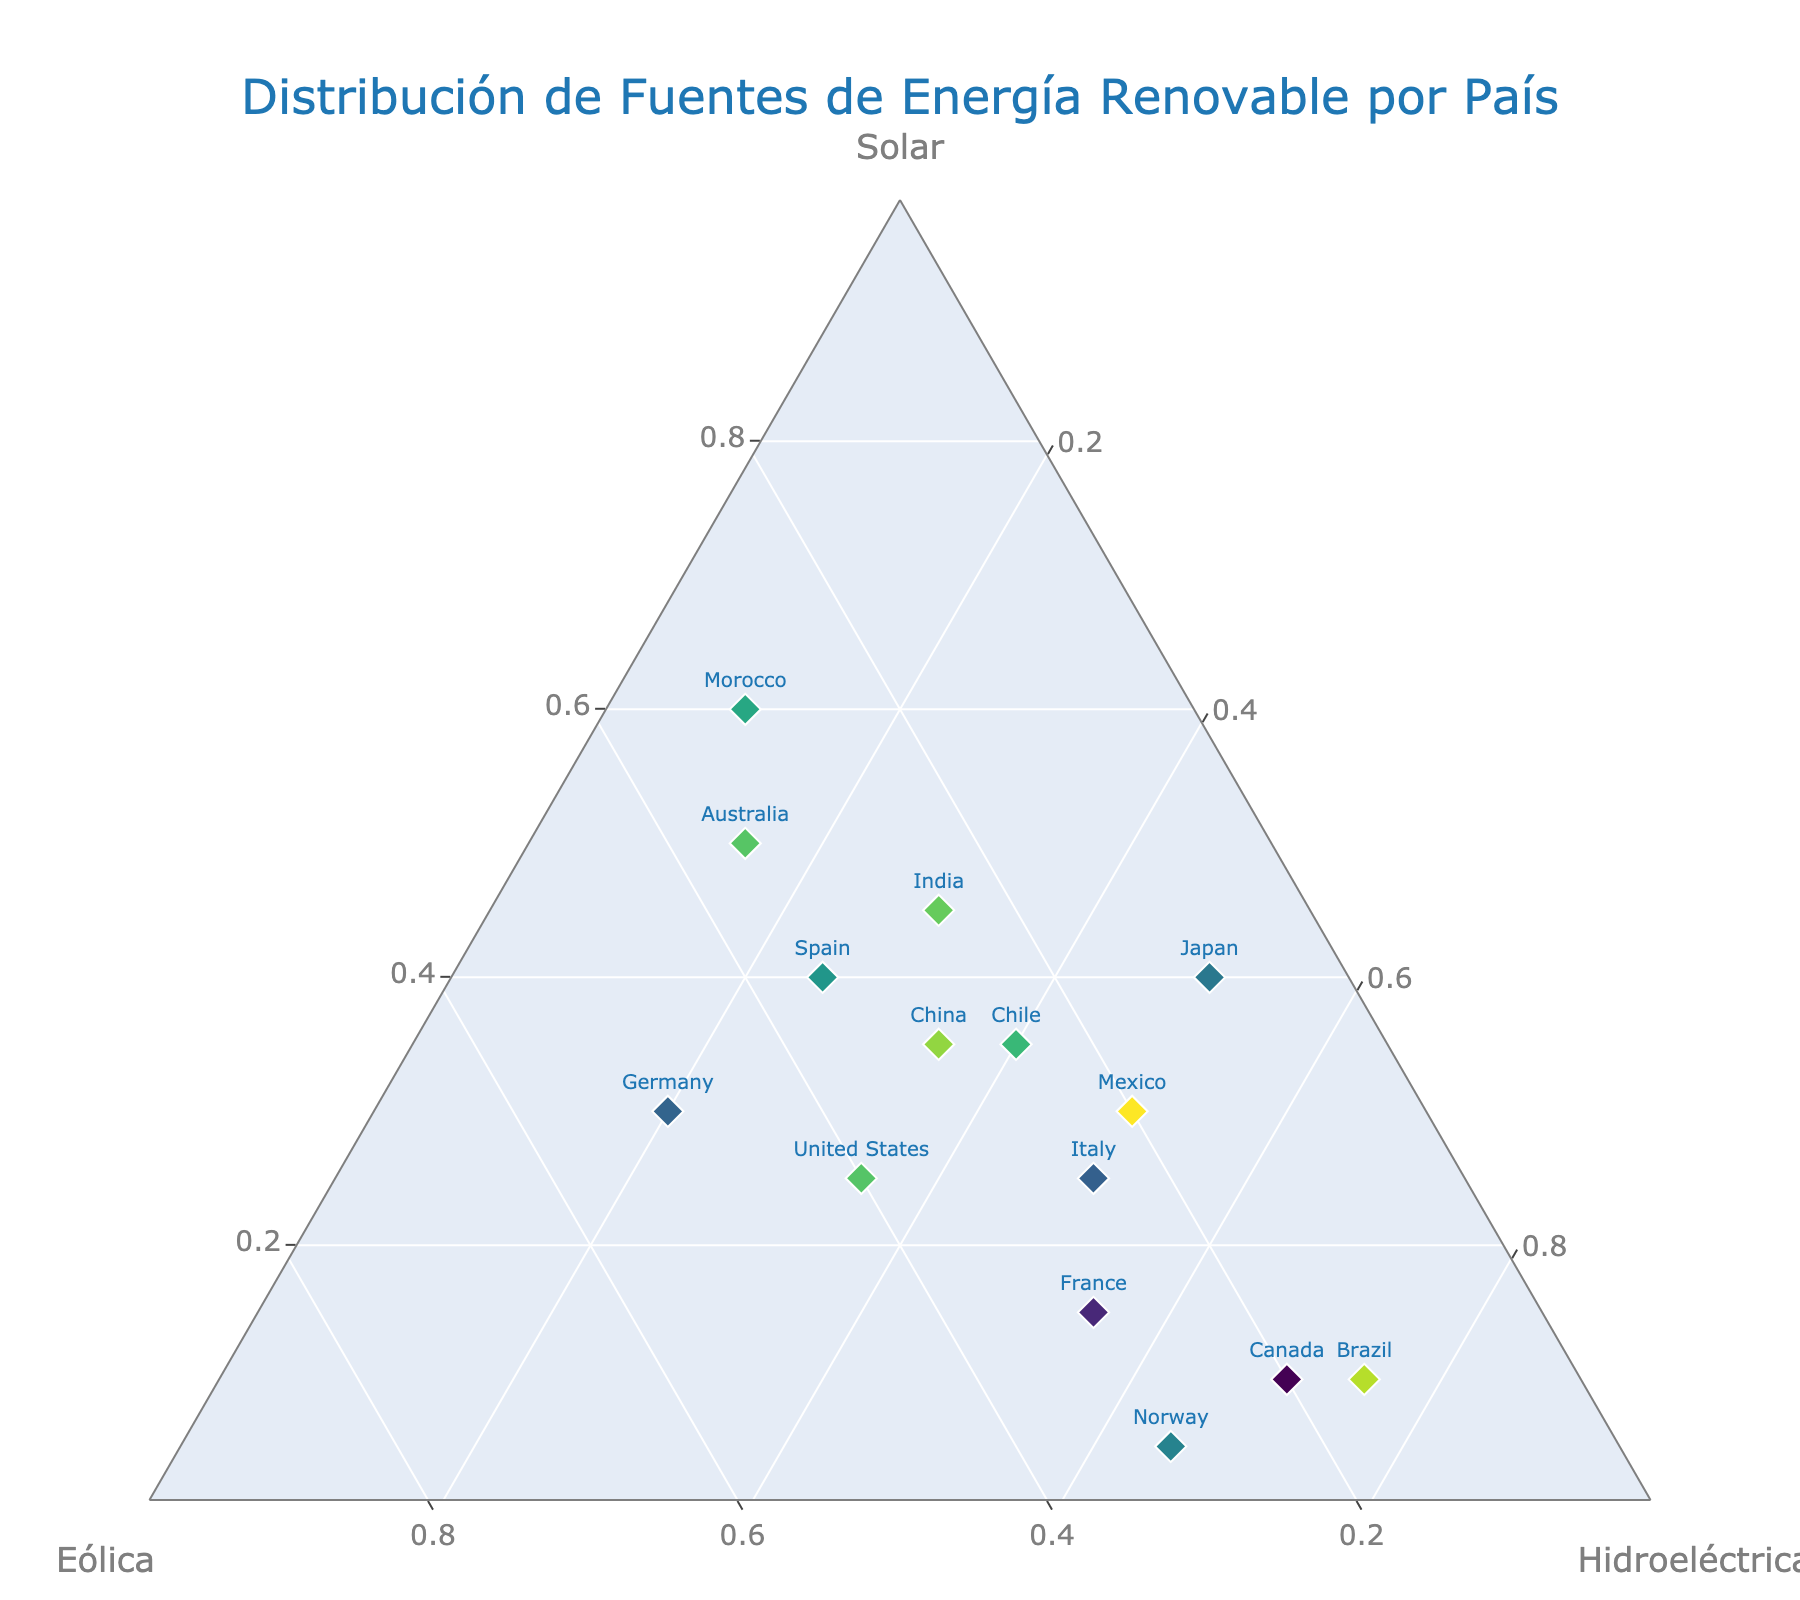What's the title of the ternary plot? The title of the plot is usually at the top center of the figure, and it summarizes the overall content. In this case, it provides an overview of what the ternary plot represents.
Answer: Distribución de Fuentes de Energía Renovable por País How many countries are represented in the plot? To determine the number of countries, count the distinct data points on the plot, each labeled with the country name.
Answer: 15 Which country has the highest proportion of solar energy? Check the data points' positions in the ternary plot. The country with the highest solar energy will have its point closest to the 'Solar' vertex.
Answer: Morocco Which two countries have a similar distribution of renewable energy sources? Look for countries with data points that are close to each other on the plot, indicating similar proportions of solar, wind, and hydroelectric energy.
Answer: Germany and United States What is the sum of the solar energy proportions for Spain and Australia? Add the solar energy proportions of Spain (40) and Australia (50) referring to their positions in the data set or plot.
Answer: 90 Which country has more wind energy, Germany or Spain? Locate the positions of Germany and Spain on the plot and compare their distances along the 'Wind' edge.
Answer: Germany Which country has the lowest proportion of hydroelectric energy? Identify the data point closest to the 'Solar' plus 'Wind' edge, which would indicate the smallest proportion of hydroelectric energy.
Answer: Morocco Which country balances almost equally between solar and hydroelectric power but has less wind power? Find the point that lies midway between 'Solar' and 'Hydroelectric' and adequately below in the 'Wind' section.
Answer: Italy Is there any country with a higher proportion of hydroelectric energy than both wind and solar combined? Compare each data point's 'Hydroelectric' proportion with the sum of its 'Solar' and 'Wind' proportions.
Answer: Brazil 